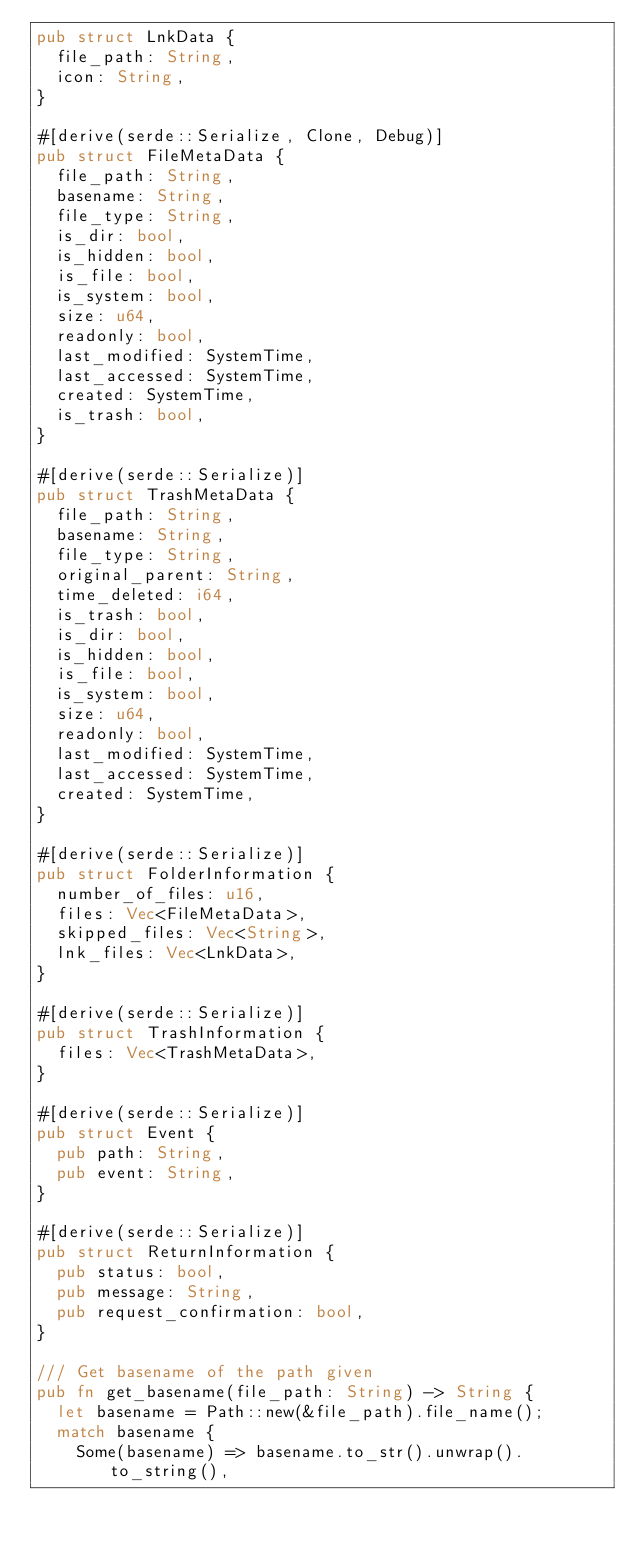Convert code to text. <code><loc_0><loc_0><loc_500><loc_500><_Rust_>pub struct LnkData {
  file_path: String,
  icon: String,
}

#[derive(serde::Serialize, Clone, Debug)]
pub struct FileMetaData {
  file_path: String,
  basename: String,
  file_type: String,
  is_dir: bool,
  is_hidden: bool,
  is_file: bool,
  is_system: bool,
  size: u64,
  readonly: bool,
  last_modified: SystemTime,
  last_accessed: SystemTime,
  created: SystemTime,
  is_trash: bool,
}

#[derive(serde::Serialize)]
pub struct TrashMetaData {
  file_path: String,
  basename: String,
  file_type: String,
  original_parent: String,
  time_deleted: i64,
  is_trash: bool,
  is_dir: bool,
  is_hidden: bool,
  is_file: bool,
  is_system: bool,
  size: u64,
  readonly: bool,
  last_modified: SystemTime,
  last_accessed: SystemTime,
  created: SystemTime,
}

#[derive(serde::Serialize)]
pub struct FolderInformation {
  number_of_files: u16,
  files: Vec<FileMetaData>,
  skipped_files: Vec<String>,
  lnk_files: Vec<LnkData>,
}

#[derive(serde::Serialize)]
pub struct TrashInformation {
  files: Vec<TrashMetaData>,
}

#[derive(serde::Serialize)]
pub struct Event {
  pub path: String,
  pub event: String,
}

#[derive(serde::Serialize)]
pub struct ReturnInformation {
  pub status: bool,
  pub message: String,
  pub request_confirmation: bool,
}

/// Get basename of the path given
pub fn get_basename(file_path: String) -> String {
  let basename = Path::new(&file_path).file_name();
  match basename {
    Some(basename) => basename.to_str().unwrap().to_string(),</code> 